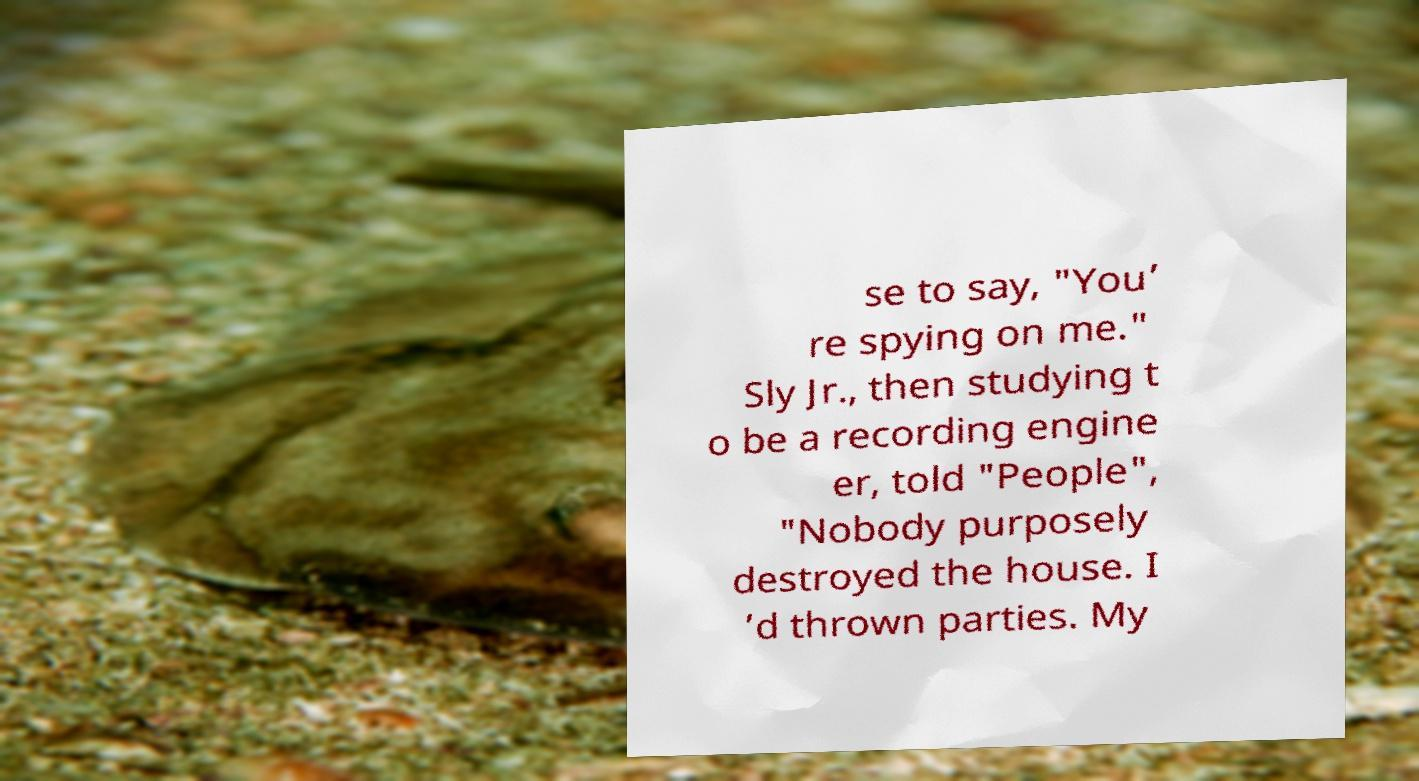Please identify and transcribe the text found in this image. se to say, "You’ re spying on me." Sly Jr., then studying t o be a recording engine er, told "People", "Nobody purposely destroyed the house. I ’d thrown parties. My 